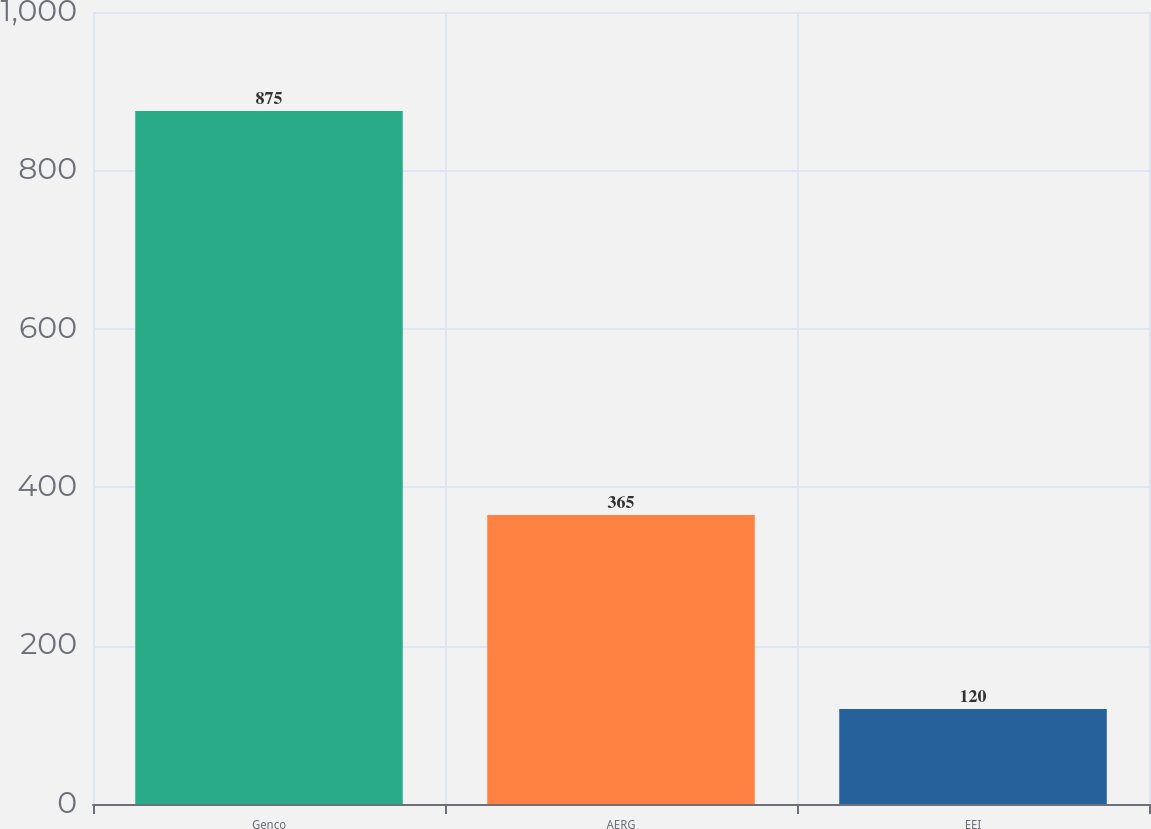Convert chart. <chart><loc_0><loc_0><loc_500><loc_500><bar_chart><fcel>Genco<fcel>AERG<fcel>EEI<nl><fcel>875<fcel>365<fcel>120<nl></chart> 